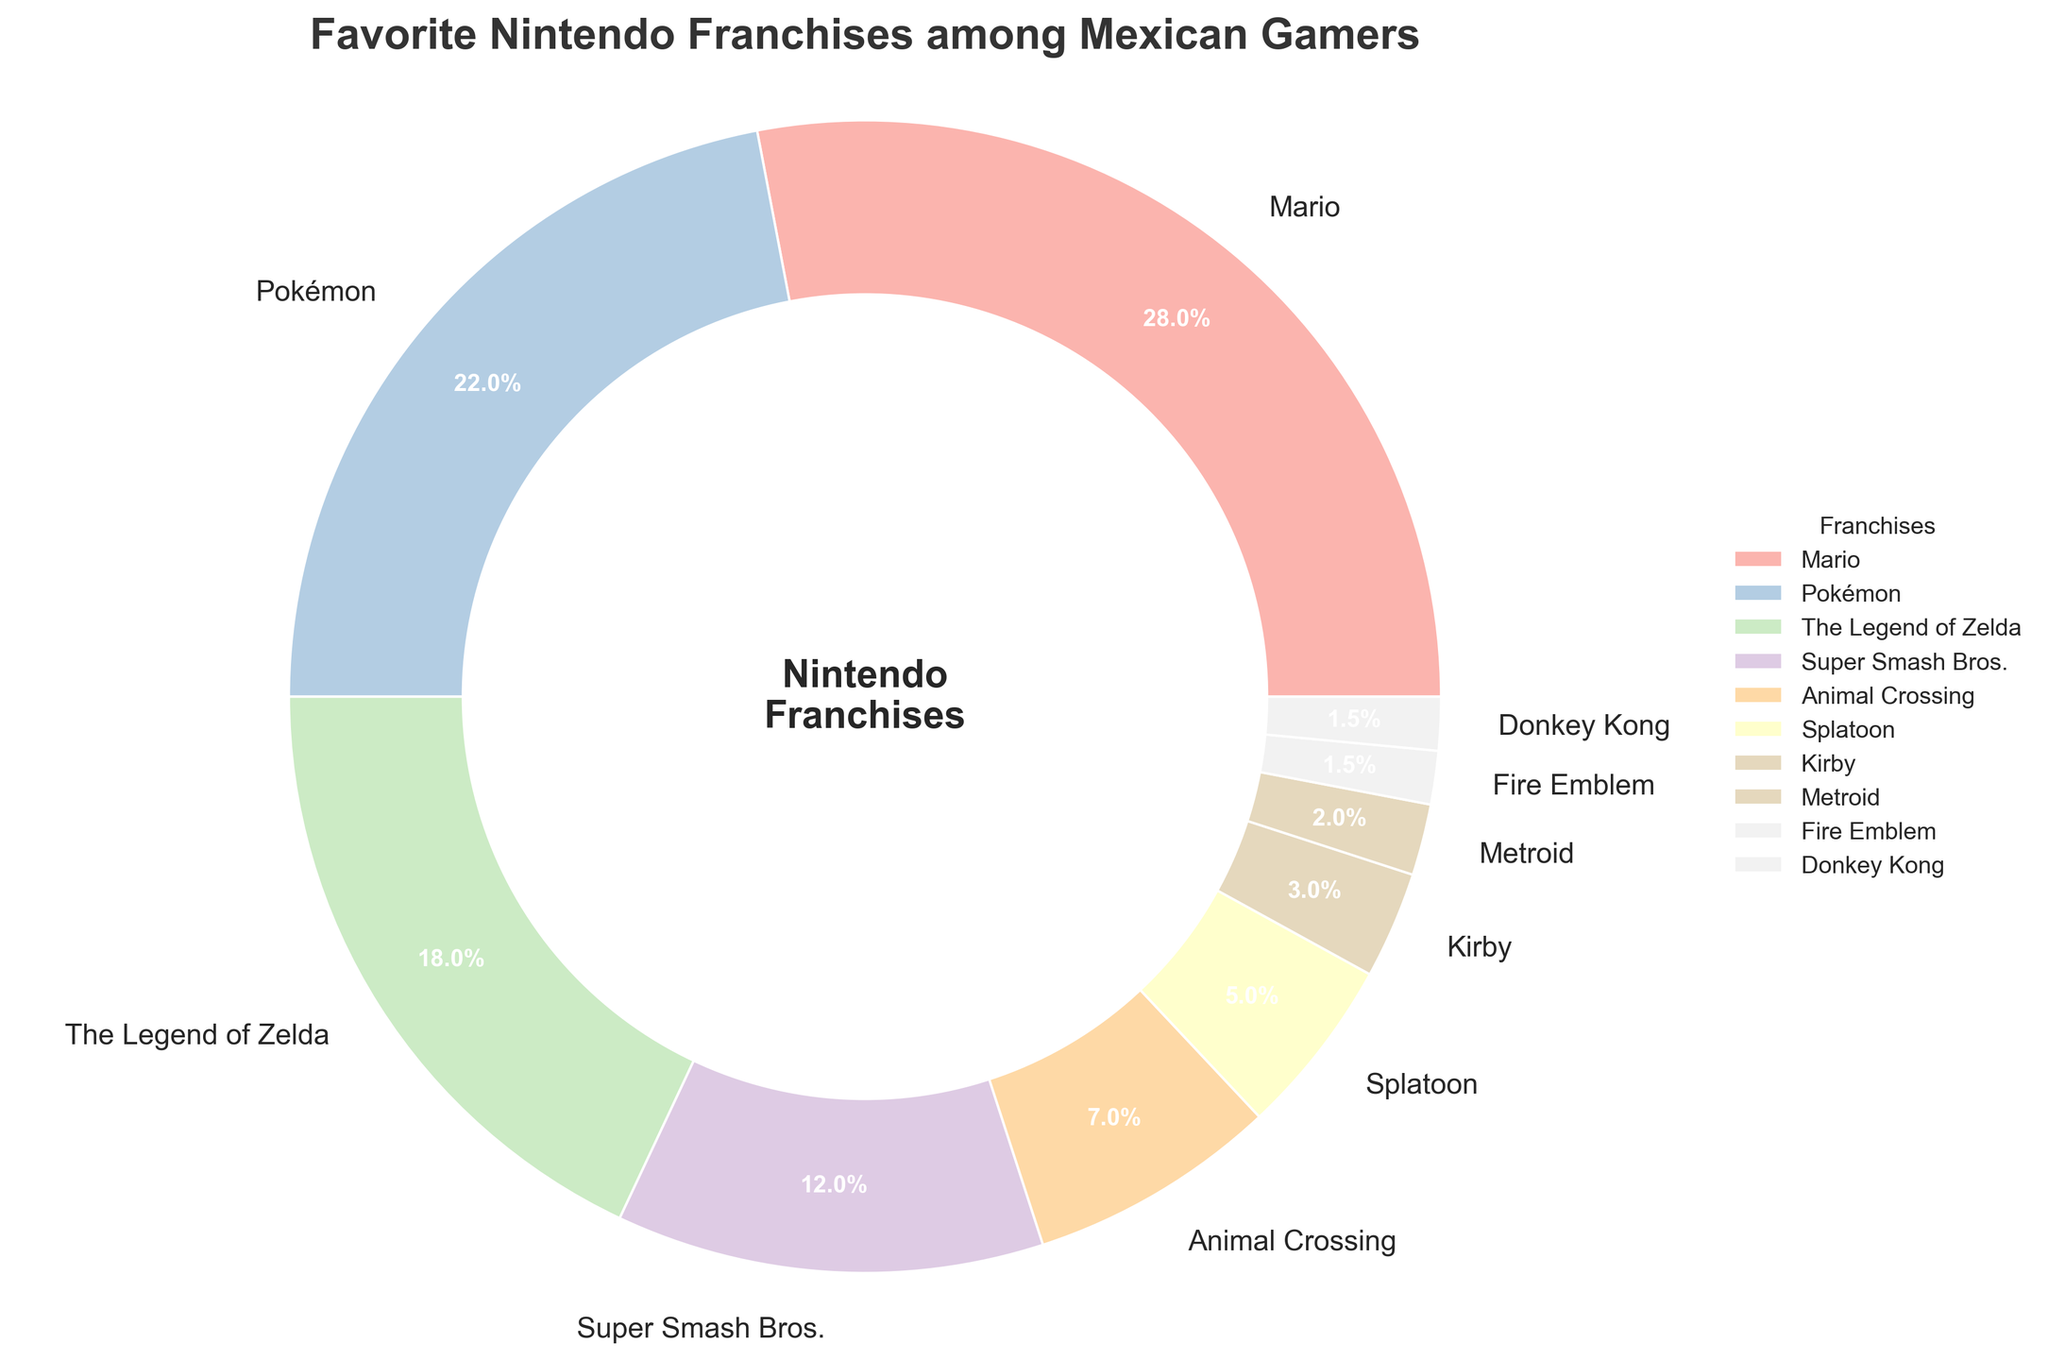What's the most popular Nintendo franchise among Mexican gamers? From the pie chart, the segment with the largest percentage is labeled "Mario" with 28%.
Answer: Mario Which Nintendo franchise has a higher percentage of fans: Pokémon or The Legend of Zelda? Comparing the two segments, Pokémon is 22% and The Legend of Zelda is 18%. Hence, Pokémon is higher.
Answer: Pokémon What's the total percentage of fans for Mario, Pokémon, and The Legend of Zelda combined? Adding the percentages of Mario (28%), Pokémon (22%), and The Legend of Zelda (18%) gives 28 + 22 + 18 = 68%.
Answer: 68% How much more popular is Mario compared to Super Smash Bros.? Subtract the percentage of Super Smash Bros. (12%) from the percentage of Mario (28%): 28 - 12 = 16%.
Answer: 16% Which franchises have percentages less than 5%? From the pie chart, the segments labeled Splatoon (5%), Kirby (3%), Metroid (2%), Fire Emblem (1.5%), and Donkey Kong (1.5%) are all less than 5%.
Answer: Splatoon, Kirby, Metroid, Fire Emblem, Donkey Kong Is the percentage of Animal Crossing fans greater than that of Splatoon fans? The pie chart shows Animal Crossing at 7% and Splatoon at 5%, so Animal Crossing has a greater percentage.
Answer: Yes How many franchises have a percentage of fans between 1% and 10%? The pie chart segments for Super Smash Bros. (12%), Animal Crossing (7%), Splatoon (5%), Kirby (3%), Metroid (2%), Fire Emblem (1.5%), and Donkey Kong (1.5%) are within this range. Counting them, we have 6 franchises.
Answer: 6 What's the least popular Nintendo franchise among the ones listed? The smallest segment in the pie chart is labeled "Fire Emblem" and "Donkey Kong," both with 1.5%.
Answer: Fire Emblem, Donkey Kong How does the popularity of Kirby compare to Metroid? Kirby is shown with a 3% segment, while Metroid is 2%, so Kirby is more popular than Metroid.
Answer: Kirby is more popular What percentage would you get if you added the percentages of Animal Crossing and Super Smash Bros.? Adding the percentages of Animal Crossing (7%) and Super Smash Bros. (12%) yields 7 + 12 = 19%.
Answer: 19% 